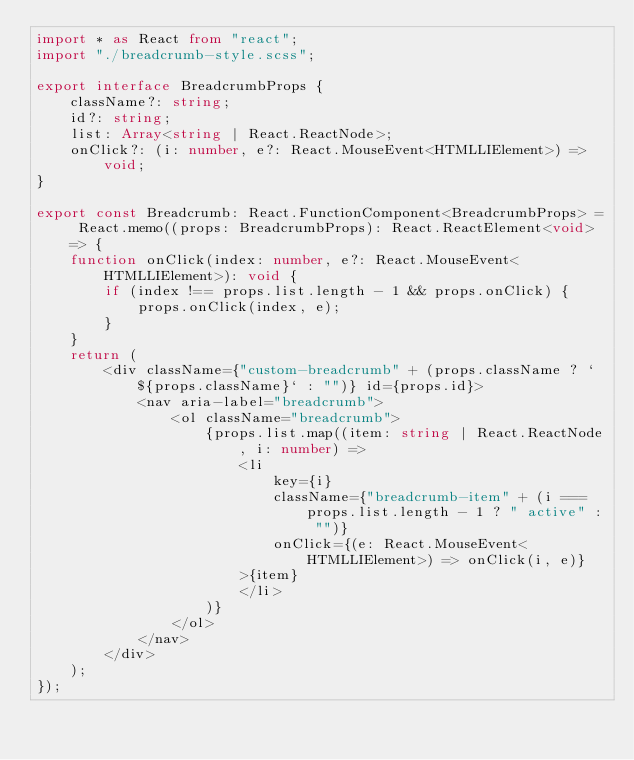<code> <loc_0><loc_0><loc_500><loc_500><_TypeScript_>import * as React from "react";
import "./breadcrumb-style.scss";

export interface BreadcrumbProps {
    className?: string;
    id?: string;
    list: Array<string | React.ReactNode>;
    onClick?: (i: number, e?: React.MouseEvent<HTMLLIElement>) => void;
}

export const Breadcrumb: React.FunctionComponent<BreadcrumbProps> = React.memo((props: BreadcrumbProps): React.ReactElement<void> => {
    function onClick(index: number, e?: React.MouseEvent<HTMLLIElement>): void {
        if (index !== props.list.length - 1 && props.onClick) {
            props.onClick(index, e);
        }
    }
    return (
        <div className={"custom-breadcrumb" + (props.className ? ` ${props.className}` : "")} id={props.id}>
            <nav aria-label="breadcrumb">
                <ol className="breadcrumb">
                    {props.list.map((item: string | React.ReactNode, i: number) =>
                        <li
                            key={i}
                            className={"breadcrumb-item" + (i === props.list.length - 1 ? " active" : "")}
                            onClick={(e: React.MouseEvent<HTMLLIElement>) => onClick(i, e)}
                        >{item}
                        </li>
                    )}
                </ol>
            </nav>
        </div>
    );
});
</code> 